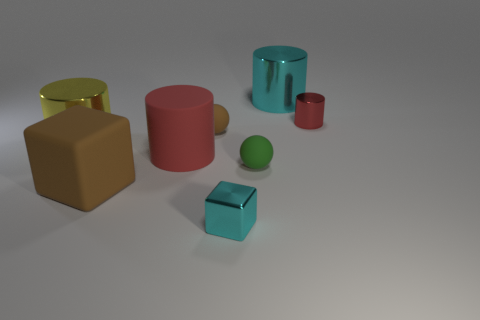Are there any small gray objects made of the same material as the large block?
Provide a succinct answer. No. How many red cylinders are both to the right of the big cyan thing and on the left side of the metallic block?
Provide a succinct answer. 0. Is the number of matte things in front of the large yellow cylinder less than the number of cyan things that are behind the big red matte cylinder?
Offer a terse response. No. Is the big yellow object the same shape as the large cyan metal thing?
Your answer should be compact. Yes. How many other things are the same size as the green rubber thing?
Provide a short and direct response. 3. What number of things are big matte objects right of the matte block or things behind the brown sphere?
Your response must be concise. 3. What number of other small matte objects are the same shape as the yellow thing?
Offer a very short reply. 0. There is a tiny object that is both on the left side of the big cyan metallic thing and right of the small cyan metal thing; what is it made of?
Offer a very short reply. Rubber. There is a shiny block; how many big yellow metallic objects are to the right of it?
Offer a terse response. 0. How many metal objects are there?
Offer a very short reply. 4. 